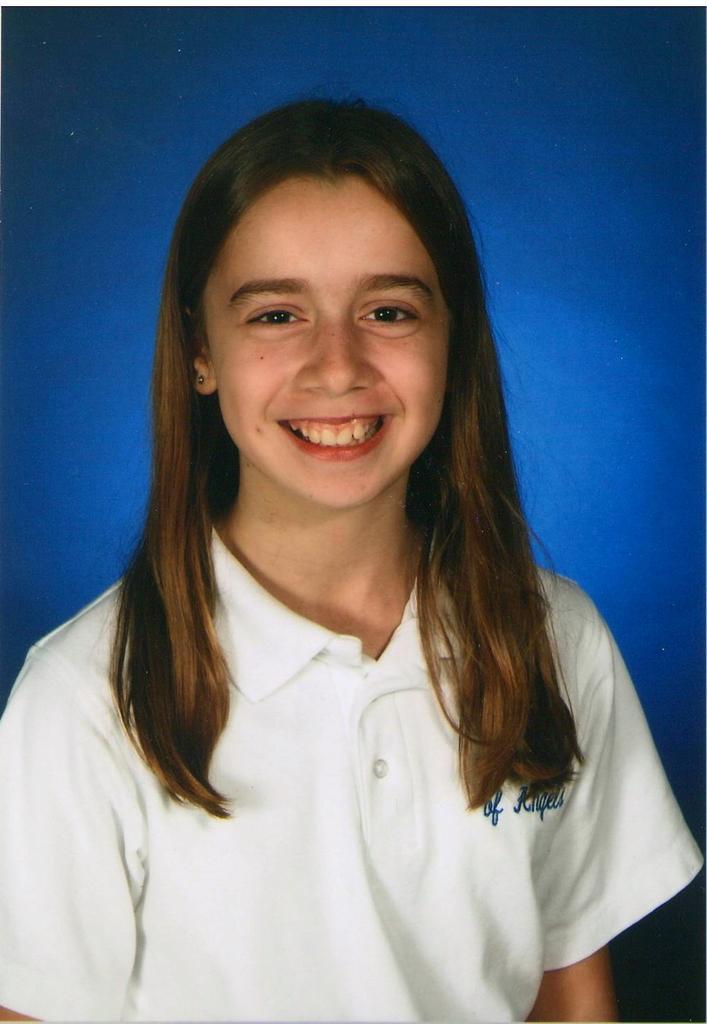Could you give a brief overview of what you see in this image? In this picture there is a woman who is wearing a white t-shirt and she is smiling. In the back I can see the blue color. 